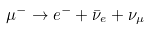<formula> <loc_0><loc_0><loc_500><loc_500>\mu ^ { - } \to e ^ { - } + \bar { \nu } _ { e } + \nu _ { \mu }</formula> 